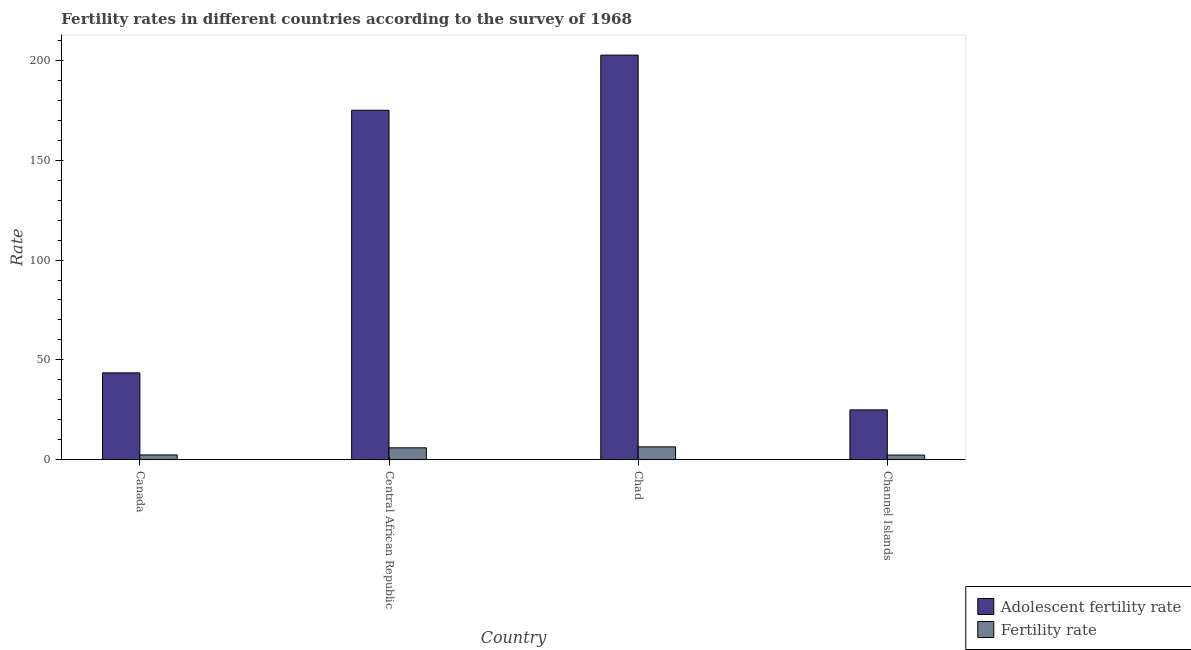How many different coloured bars are there?
Give a very brief answer. 2. Are the number of bars per tick equal to the number of legend labels?
Provide a short and direct response. Yes. Are the number of bars on each tick of the X-axis equal?
Provide a short and direct response. Yes. How many bars are there on the 1st tick from the right?
Keep it short and to the point. 2. What is the label of the 3rd group of bars from the left?
Give a very brief answer. Chad. What is the adolescent fertility rate in Central African Republic?
Provide a short and direct response. 175.05. Across all countries, what is the maximum adolescent fertility rate?
Provide a succinct answer. 202.66. Across all countries, what is the minimum fertility rate?
Offer a terse response. 2.32. In which country was the adolescent fertility rate maximum?
Give a very brief answer. Chad. In which country was the adolescent fertility rate minimum?
Make the answer very short. Channel Islands. What is the total fertility rate in the graph?
Offer a very short reply. 17.09. What is the difference between the adolescent fertility rate in Canada and that in Chad?
Your answer should be compact. -159.17. What is the difference between the adolescent fertility rate in Chad and the fertility rate in Central African Republic?
Your answer should be very brief. 196.71. What is the average adolescent fertility rate per country?
Make the answer very short. 111.54. What is the difference between the fertility rate and adolescent fertility rate in Central African Republic?
Offer a terse response. -169.1. What is the ratio of the fertility rate in Canada to that in Central African Republic?
Provide a succinct answer. 0.4. What is the difference between the highest and the second highest adolescent fertility rate?
Your answer should be compact. 27.61. What is the difference between the highest and the lowest adolescent fertility rate?
Your answer should be compact. 177.71. What does the 1st bar from the left in Central African Republic represents?
Provide a succinct answer. Adolescent fertility rate. What does the 1st bar from the right in Canada represents?
Make the answer very short. Fertility rate. Are all the bars in the graph horizontal?
Keep it short and to the point. No. How many countries are there in the graph?
Give a very brief answer. 4. What is the difference between two consecutive major ticks on the Y-axis?
Keep it short and to the point. 50. Are the values on the major ticks of Y-axis written in scientific E-notation?
Keep it short and to the point. No. Does the graph contain grids?
Your response must be concise. No. Where does the legend appear in the graph?
Your answer should be compact. Bottom right. How many legend labels are there?
Your answer should be compact. 2. How are the legend labels stacked?
Your answer should be compact. Vertical. What is the title of the graph?
Provide a succinct answer. Fertility rates in different countries according to the survey of 1968. Does "Age 65(female)" appear as one of the legend labels in the graph?
Offer a very short reply. No. What is the label or title of the Y-axis?
Keep it short and to the point. Rate. What is the Rate of Adolescent fertility rate in Canada?
Offer a very short reply. 43.49. What is the Rate of Fertility rate in Canada?
Ensure brevity in your answer.  2.39. What is the Rate in Adolescent fertility rate in Central African Republic?
Ensure brevity in your answer.  175.05. What is the Rate of Fertility rate in Central African Republic?
Provide a succinct answer. 5.95. What is the Rate of Adolescent fertility rate in Chad?
Your answer should be compact. 202.66. What is the Rate of Fertility rate in Chad?
Provide a succinct answer. 6.43. What is the Rate of Adolescent fertility rate in Channel Islands?
Your response must be concise. 24.95. What is the Rate in Fertility rate in Channel Islands?
Make the answer very short. 2.32. Across all countries, what is the maximum Rate in Adolescent fertility rate?
Your answer should be very brief. 202.66. Across all countries, what is the maximum Rate in Fertility rate?
Your response must be concise. 6.43. Across all countries, what is the minimum Rate in Adolescent fertility rate?
Offer a very short reply. 24.95. Across all countries, what is the minimum Rate of Fertility rate?
Make the answer very short. 2.32. What is the total Rate in Adolescent fertility rate in the graph?
Keep it short and to the point. 446.16. What is the total Rate in Fertility rate in the graph?
Your response must be concise. 17.09. What is the difference between the Rate of Adolescent fertility rate in Canada and that in Central African Republic?
Offer a very short reply. -131.55. What is the difference between the Rate in Fertility rate in Canada and that in Central African Republic?
Your answer should be compact. -3.57. What is the difference between the Rate in Adolescent fertility rate in Canada and that in Chad?
Offer a very short reply. -159.17. What is the difference between the Rate in Fertility rate in Canada and that in Chad?
Your response must be concise. -4.05. What is the difference between the Rate of Adolescent fertility rate in Canada and that in Channel Islands?
Your response must be concise. 18.54. What is the difference between the Rate of Fertility rate in Canada and that in Channel Islands?
Offer a terse response. 0.07. What is the difference between the Rate in Adolescent fertility rate in Central African Republic and that in Chad?
Your answer should be very brief. -27.61. What is the difference between the Rate of Fertility rate in Central African Republic and that in Chad?
Ensure brevity in your answer.  -0.48. What is the difference between the Rate in Adolescent fertility rate in Central African Republic and that in Channel Islands?
Make the answer very short. 150.1. What is the difference between the Rate of Fertility rate in Central African Republic and that in Channel Islands?
Your answer should be compact. 3.63. What is the difference between the Rate of Adolescent fertility rate in Chad and that in Channel Islands?
Keep it short and to the point. 177.71. What is the difference between the Rate of Fertility rate in Chad and that in Channel Islands?
Your answer should be compact. 4.11. What is the difference between the Rate of Adolescent fertility rate in Canada and the Rate of Fertility rate in Central African Republic?
Your response must be concise. 37.54. What is the difference between the Rate of Adolescent fertility rate in Canada and the Rate of Fertility rate in Chad?
Give a very brief answer. 37.06. What is the difference between the Rate in Adolescent fertility rate in Canada and the Rate in Fertility rate in Channel Islands?
Keep it short and to the point. 41.18. What is the difference between the Rate of Adolescent fertility rate in Central African Republic and the Rate of Fertility rate in Chad?
Give a very brief answer. 168.62. What is the difference between the Rate in Adolescent fertility rate in Central African Republic and the Rate in Fertility rate in Channel Islands?
Provide a short and direct response. 172.73. What is the difference between the Rate of Adolescent fertility rate in Chad and the Rate of Fertility rate in Channel Islands?
Give a very brief answer. 200.34. What is the average Rate in Adolescent fertility rate per country?
Provide a short and direct response. 111.54. What is the average Rate of Fertility rate per country?
Keep it short and to the point. 4.27. What is the difference between the Rate in Adolescent fertility rate and Rate in Fertility rate in Canada?
Offer a very short reply. 41.11. What is the difference between the Rate in Adolescent fertility rate and Rate in Fertility rate in Central African Republic?
Provide a succinct answer. 169.1. What is the difference between the Rate in Adolescent fertility rate and Rate in Fertility rate in Chad?
Give a very brief answer. 196.23. What is the difference between the Rate of Adolescent fertility rate and Rate of Fertility rate in Channel Islands?
Provide a short and direct response. 22.63. What is the ratio of the Rate of Adolescent fertility rate in Canada to that in Central African Republic?
Provide a succinct answer. 0.25. What is the ratio of the Rate in Fertility rate in Canada to that in Central African Republic?
Your answer should be very brief. 0.4. What is the ratio of the Rate of Adolescent fertility rate in Canada to that in Chad?
Ensure brevity in your answer.  0.21. What is the ratio of the Rate of Fertility rate in Canada to that in Chad?
Make the answer very short. 0.37. What is the ratio of the Rate of Adolescent fertility rate in Canada to that in Channel Islands?
Provide a short and direct response. 1.74. What is the ratio of the Rate in Fertility rate in Canada to that in Channel Islands?
Give a very brief answer. 1.03. What is the ratio of the Rate of Adolescent fertility rate in Central African Republic to that in Chad?
Your answer should be compact. 0.86. What is the ratio of the Rate in Fertility rate in Central African Republic to that in Chad?
Ensure brevity in your answer.  0.93. What is the ratio of the Rate in Adolescent fertility rate in Central African Republic to that in Channel Islands?
Provide a short and direct response. 7.02. What is the ratio of the Rate of Fertility rate in Central African Republic to that in Channel Islands?
Provide a succinct answer. 2.57. What is the ratio of the Rate in Adolescent fertility rate in Chad to that in Channel Islands?
Provide a short and direct response. 8.12. What is the ratio of the Rate in Fertility rate in Chad to that in Channel Islands?
Offer a terse response. 2.77. What is the difference between the highest and the second highest Rate in Adolescent fertility rate?
Give a very brief answer. 27.61. What is the difference between the highest and the second highest Rate of Fertility rate?
Provide a short and direct response. 0.48. What is the difference between the highest and the lowest Rate in Adolescent fertility rate?
Keep it short and to the point. 177.71. What is the difference between the highest and the lowest Rate of Fertility rate?
Offer a terse response. 4.11. 